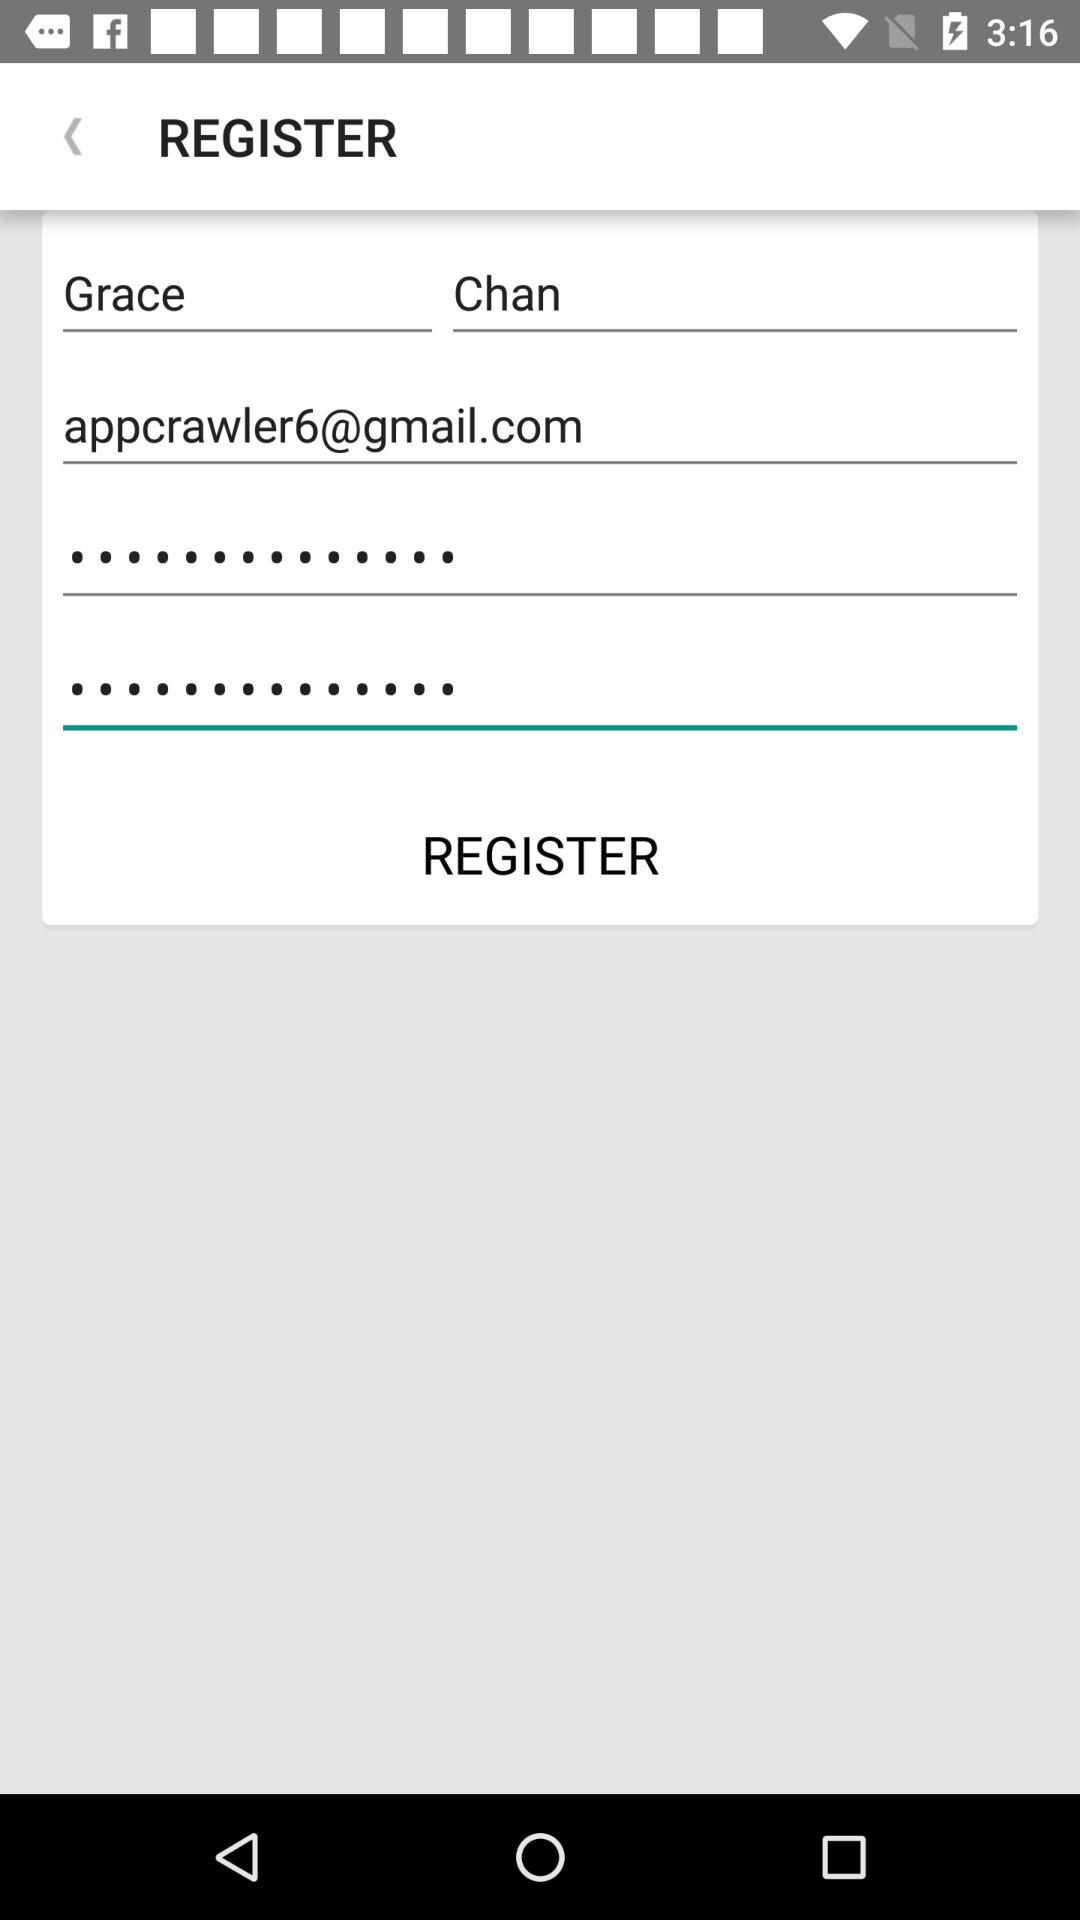What is the email address? The email address is appcrawler6@gmail.com. 